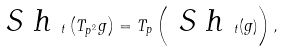<formula> <loc_0><loc_0><loc_500><loc_500>\emph { S h } _ { t } \left ( T _ { p ^ { 2 } } g \right ) = T _ { p } \left ( \emph { S h } _ { t } ( g ) \right ) ,</formula> 